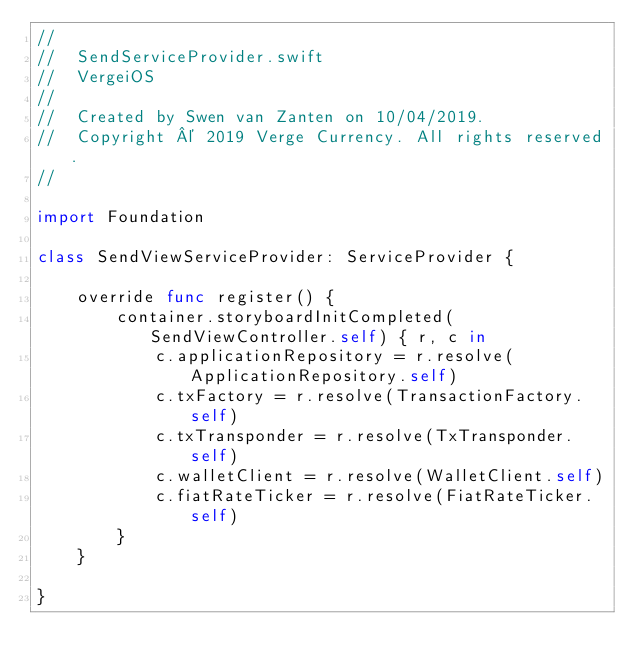Convert code to text. <code><loc_0><loc_0><loc_500><loc_500><_Swift_>//
//  SendServiceProvider.swift
//  VergeiOS
//
//  Created by Swen van Zanten on 10/04/2019.
//  Copyright © 2019 Verge Currency. All rights reserved.
//

import Foundation

class SendViewServiceProvider: ServiceProvider {
    
    override func register() {
        container.storyboardInitCompleted(SendViewController.self) { r, c in
            c.applicationRepository = r.resolve(ApplicationRepository.self)
            c.txFactory = r.resolve(TransactionFactory.self)
            c.txTransponder = r.resolve(TxTransponder.self)
            c.walletClient = r.resolve(WalletClient.self)
            c.fiatRateTicker = r.resolve(FiatRateTicker.self)
        }
    }
    
}
</code> 